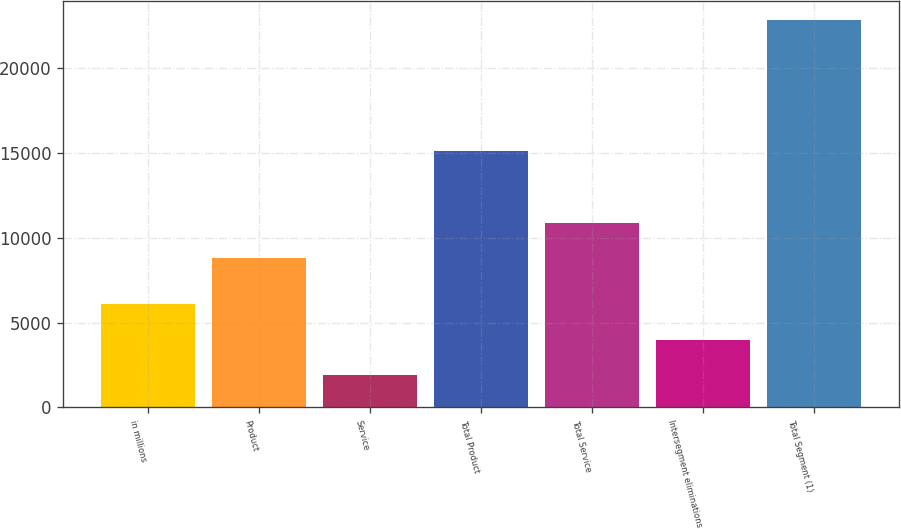Convert chart. <chart><loc_0><loc_0><loc_500><loc_500><bar_chart><fcel>in millions<fcel>Product<fcel>Service<fcel>Total Product<fcel>Total Service<fcel>Intersegment eliminations<fcel>Total Segment (1)<nl><fcel>6088.8<fcel>8796<fcel>1900<fcel>15137<fcel>10890.4<fcel>3994.4<fcel>22844<nl></chart> 